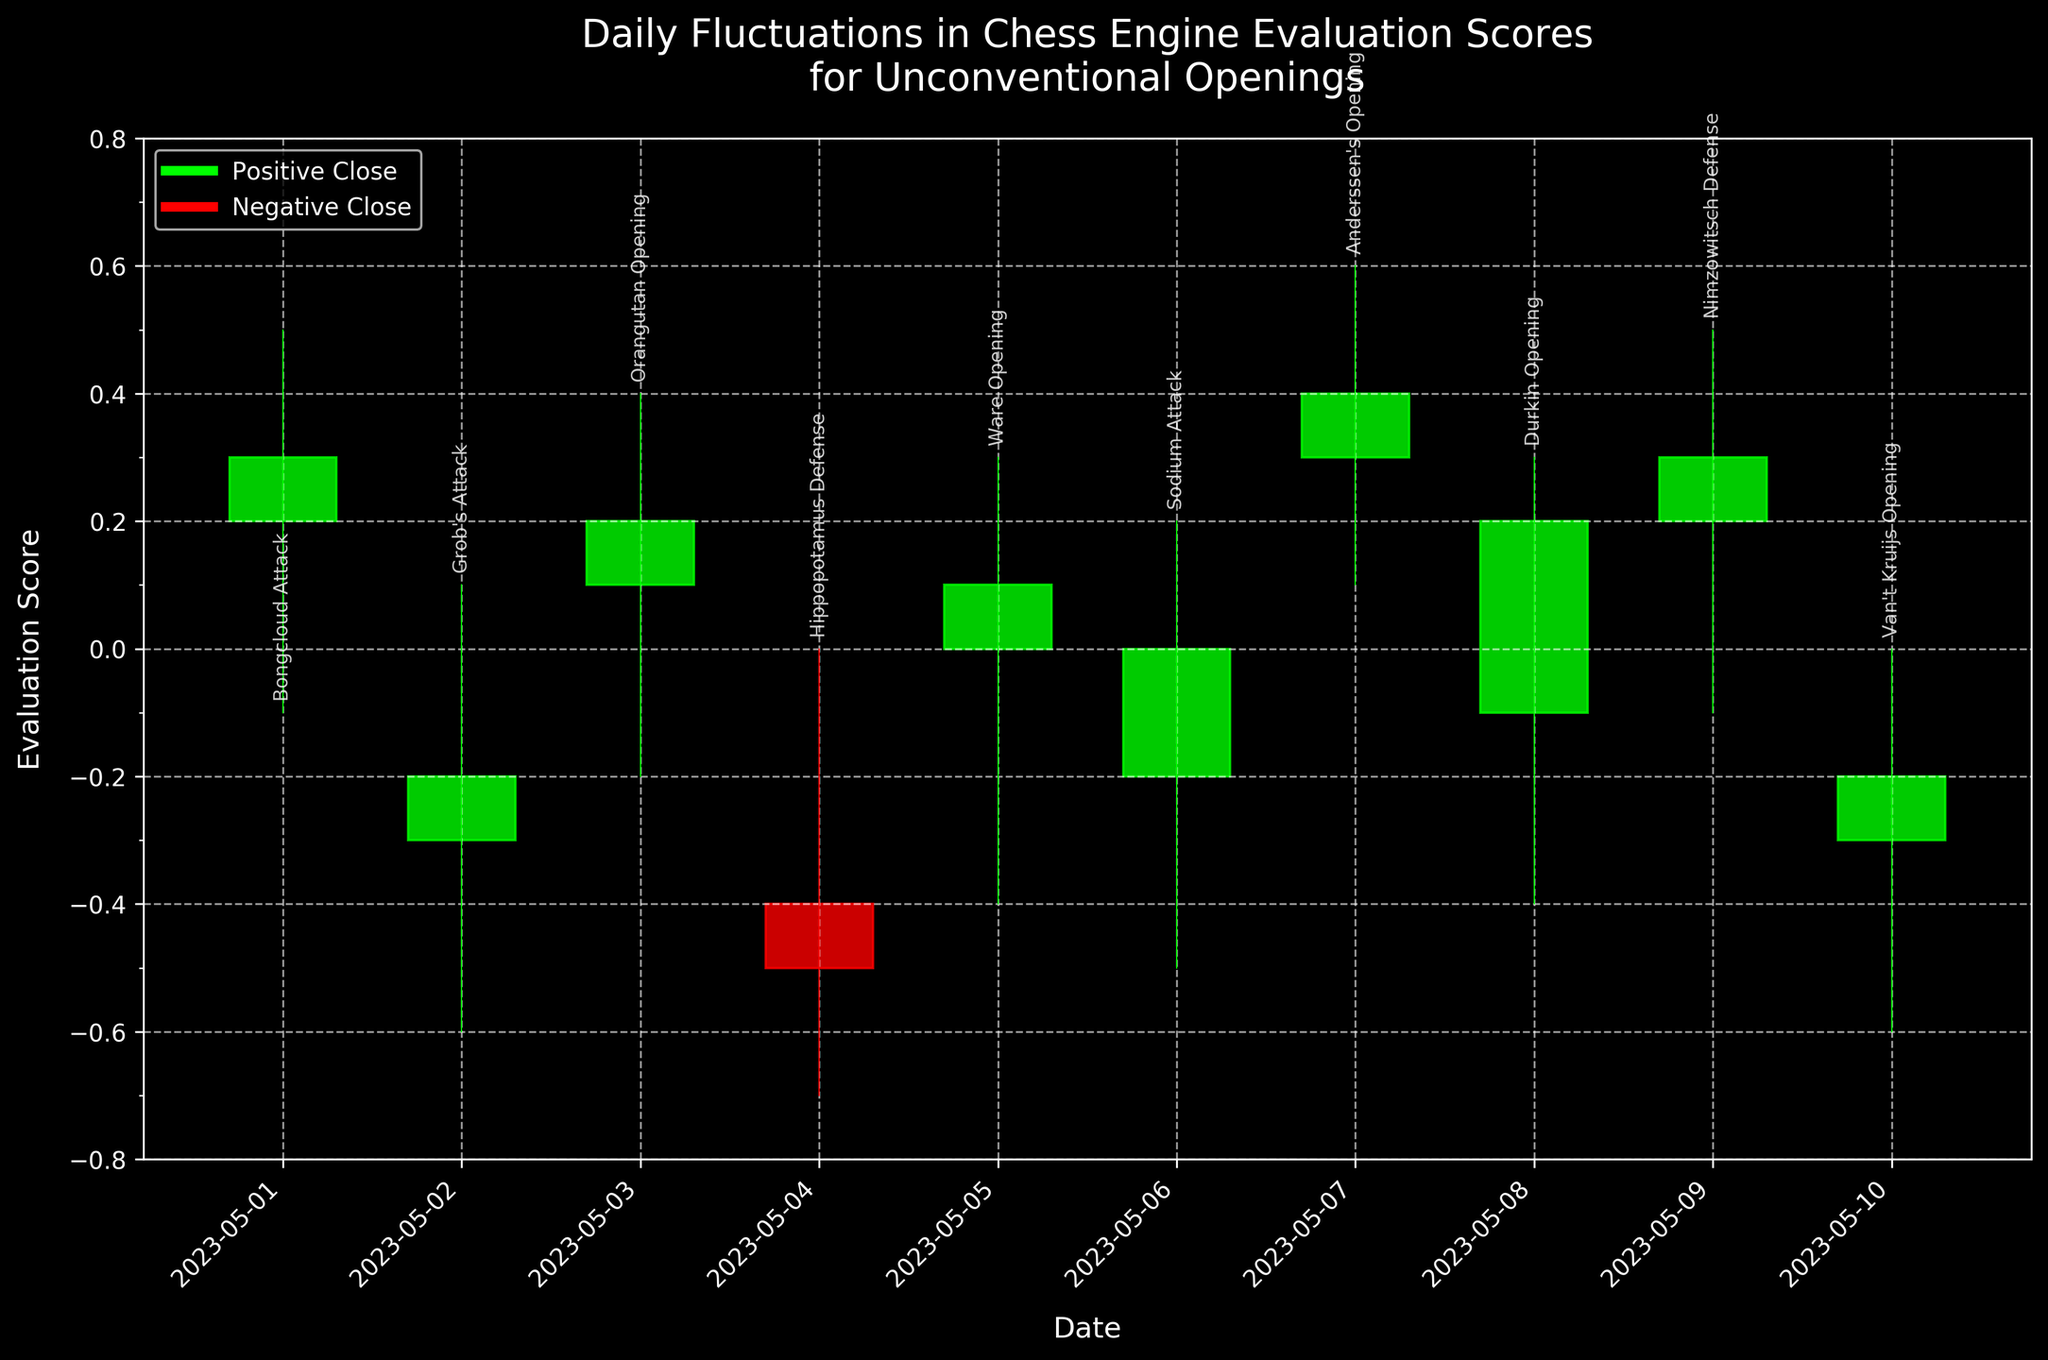What is the title of the figure? The title of the figure is located at the top center of the chart. It provides an overall description of what is being shown.
Answer: Daily Fluctuations in Chess Engine Evaluation Scores for Unconventional Openings How many days of data are displayed in the figure? The x-axis ticks represent dates, and by counting the number of distinct dates shown on the x-axis, you can determine the number of days of data displayed.
Answer: 10 Which opening had the highest evaluation score at any point, and what was the value? The 'High' value is represented by the top of the candlestick wick. By observing the chart, the highest point can be identified.
Answer: Anderssen's Opening, 0.6 Which day observed the largest drop from High to Low for an opening? The drop from High to Low can be calculated as High minus Low for each day. By observing each candlestick, the day with the largest drop can be identified.
Answer: 2023-05-04 Compare the evaluation score for Grob's Attack and Bongcloud Attack on their respective days. Which had a better Close value? The 'Close' value for each day is represented by the top or bottom of the candlestick body. By comparing the 'Close' values directly from the candlesticks of both days, a comparison can be made.
Answer: Bongcloud Attack What pattern can be observed in the daily fluctuations for the Orangutan Opening? By focusing on the candlestick for Orangutan Opening, one can see the overall trend: 'Open', 'High', 'Low', and 'Close' values.
Answer: Slight positive trend Which opening saw a positive evaluation score on both opening and closing values? This can be determined by checking if both 'Open' and 'Close' values are above zero for each candlestick.
Answer: Anderssen's Opening What is the average 'Close' value for all the openings displayed? Sum up all the 'Close' values for each day and divide by the number of days.
Answer: 0.06 What is the range of evaluation scores that the chart's y-axis covers? The y-axis limits can be read directly off the chart by looking at the lowest and highest values shown.
Answer: -0.8 to 0.8 On which day did the Hippopotamus Defense have the lowest evaluation score, and what was it? The 'Low' value for each day is shown by the bottom of the candlestick wick. The day with the lowest 'Low' value for Hippopotamus Defense can be identified.
Answer: 2023-05-04, -0.7 